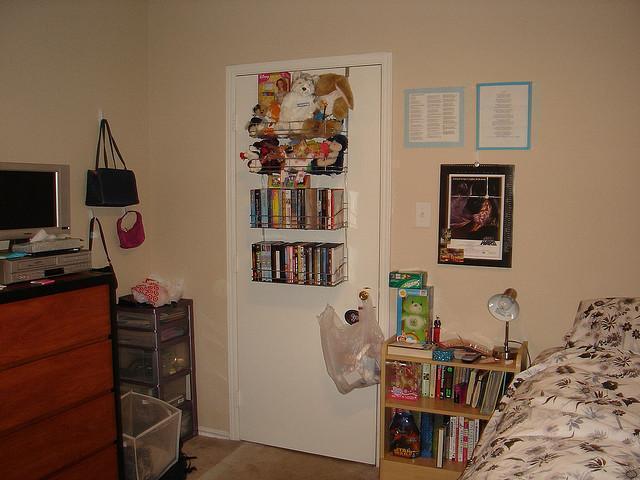What is the plastic bag on the door handle being used to collect?
Indicate the correct response and explain using: 'Answer: answer
Rationale: rationale.'
Options: Baseball cards, food, laundry, garbage. Answer: garbage.
Rationale: They don't have a bin in the room 